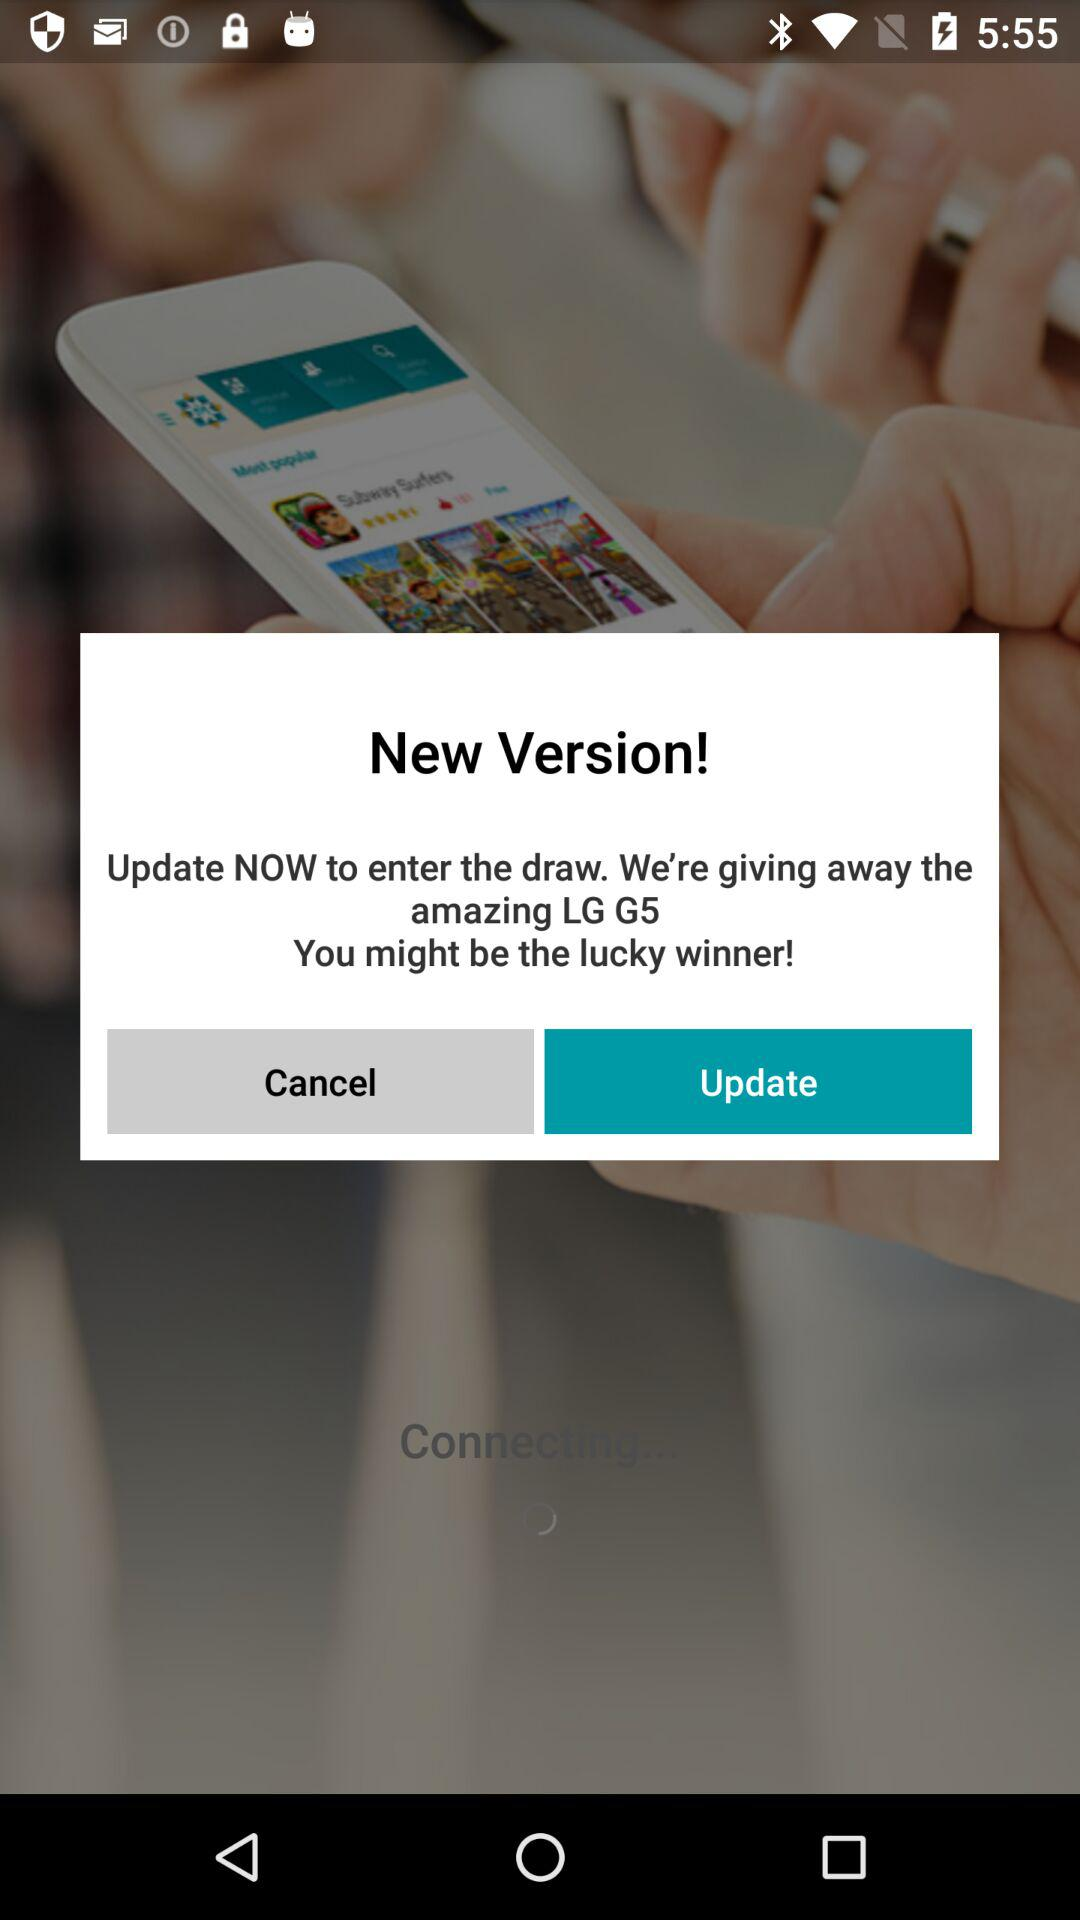What are they giving to the lucky winner? They are giving LG G5 to the lucky winner. 